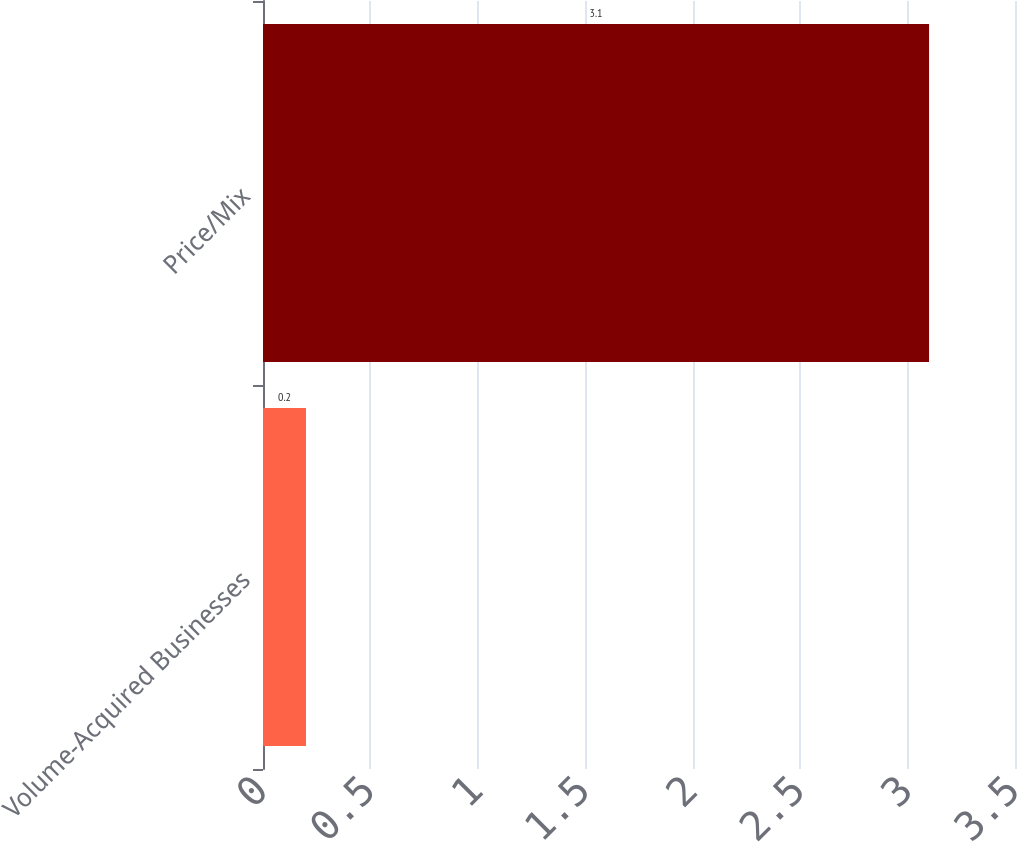Convert chart. <chart><loc_0><loc_0><loc_500><loc_500><bar_chart><fcel>Volume-Acquired Businesses<fcel>Price/Mix<nl><fcel>0.2<fcel>3.1<nl></chart> 